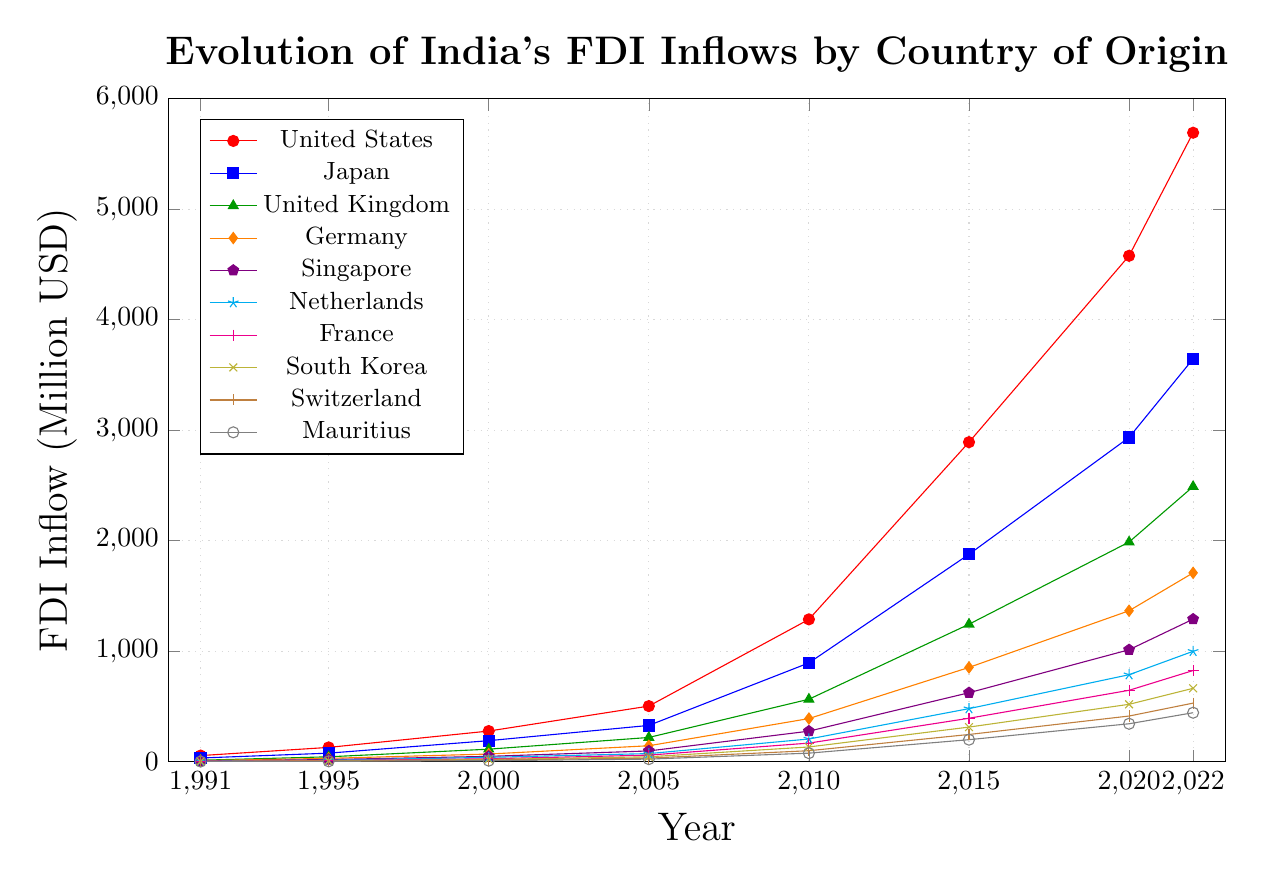What is the highest FDI inflow recorded in the given period and which country does it correspond to? The highest FDI inflow recorded in the given period is found by picking the largest value across all series. Among them, the highest value is 5692 million USD from the United States in the year 2022.
Answer: 5692 million USD, United States Between which consecutive years did Japan see the largest increase in FDI inflows? To find this, we calculate the differences in Japan's FDI inflows between consecutive years: 1991-1995: 44, 1995-2000: 113, 2000-2005: 138, 2005-2010: 566, 2010-2015: 983, 2015-2020: 1058, 2020-2022: 711. The largest increase is between 2015 and 2020 with 1058 million USD.
Answer: 2015-2020 Which country had the smallest FDI inflow in 1991, and what was the inflow value? By looking at the values for all countries in 1991, Mauritius had the smallest FDI inflow with 0 million USD.
Answer: Mauritius, 0 million USD How does the FDI inflow from Germany in 2000 compare with that from France in the same year? By observing the FDI values for the year 2000, Germany had an inflow of 68 million USD while France had 25 million USD. Thus, Germany's inflow was higher than that of France.
Answer: Germany's FDI inflow was higher What is the average FDI inflow from Singapore over the period 1991-2022? To find the average FDI inflow from Singapore, we sum the values for all the given years and divide by the number of years: (5 + 18 + 47 + 96 + 275 + 623 + 1012 + 1289) = 3365. There are 8 data points, so 3365/8 = 420.625 million USD.
Answer: 420.625 million USD In which year did the Netherlands and Switzerland have equal FDI inflows? By comparing the values for the Netherlands and Switzerland across all years, we find that in the year 1995, both had an equal FDI inflow of 4 million USD.
Answer: 1995 Which country showed a consistent increase in FDI inflows every recorded year? By examining the data across years, the United States shows consistently increasing values without any drop: 54, 128, 276, 502, 1287, 2891, 4578, 5692.
Answer: United States What is the sum of FDI inflows from the United Kingdom and Germany in the year 2022? Adding the FDI inflows for the United Kingdom (2489) and Germany (1708) in 2022 gives us: 2489 + 1708 = 4197 million USD.
Answer: 4197 million USD How much more was the FDI inflow from Japan compared to South Korea in 2015? In 2015, Japan's FDI inflow was 1876 million USD while South Korea's was 312 million USD. The difference is 1876 - 312 = 1564 million USD.
Answer: 1564 million USD 